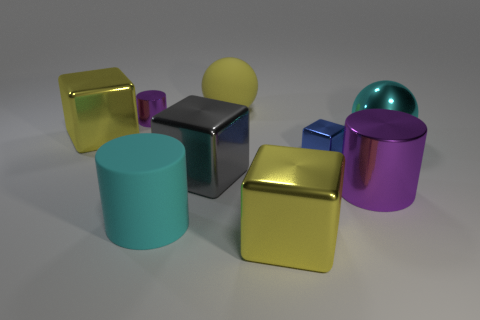What time of day does the lighting in this image suggest? The lighting in the image appears neutral and does not strongly suggest a particular time of day. It seems to be a studio set up with an artificial ambient light commonly used for product visualization. 